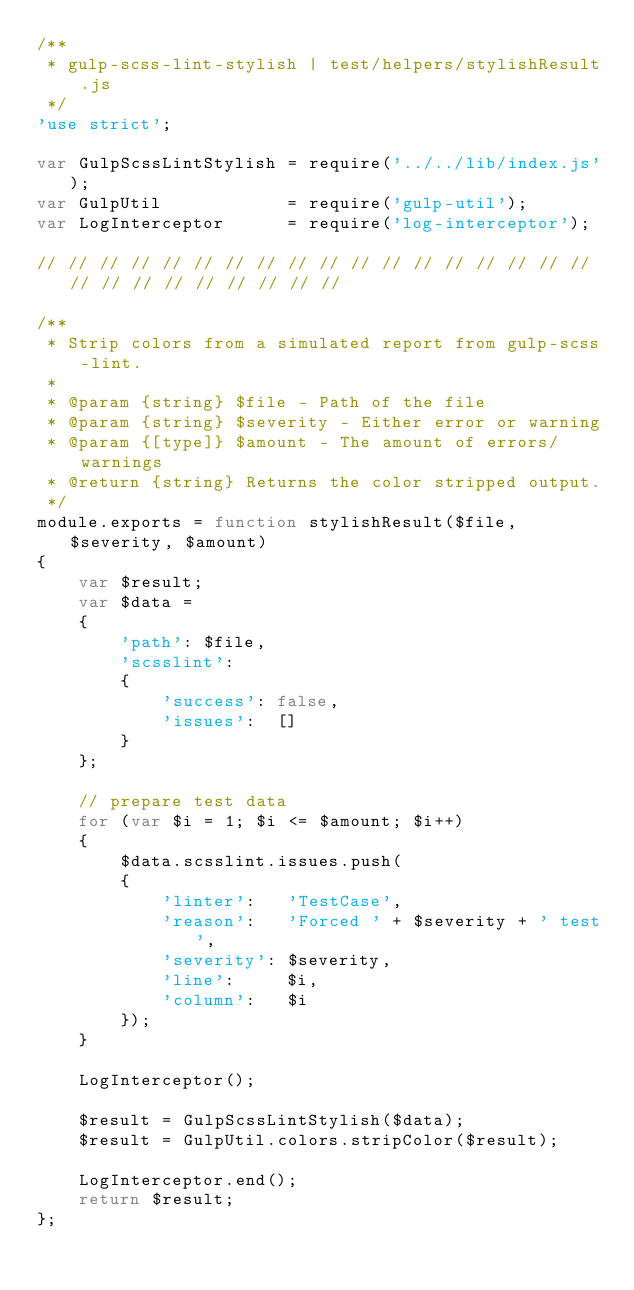Convert code to text. <code><loc_0><loc_0><loc_500><loc_500><_JavaScript_>/**
 * gulp-scss-lint-stylish | test/helpers/stylishResult.js
 */
'use strict';

var GulpScssLintStylish = require('../../lib/index.js');
var GulpUtil            = require('gulp-util');
var LogInterceptor      = require('log-interceptor');

// // // // // // // // // // // // // // // // // // // // // // // // // // //

/**
 * Strip colors from a simulated report from gulp-scss-lint.
 *
 * @param {string} $file - Path of the file
 * @param {string} $severity - Either error or warning
 * @param {[type]} $amount - The amount of errors/warnings
 * @return {string} Returns the color stripped output.
 */
module.exports = function stylishResult($file, $severity, $amount)
{
    var $result;
    var $data =
    {
        'path': $file,
        'scsslint':
        {
            'success': false,
            'issues':  []
        }
    };

    // prepare test data
    for (var $i = 1; $i <= $amount; $i++)
    {
        $data.scsslint.issues.push(
        {
            'linter':   'TestCase',
            'reason':   'Forced ' + $severity + ' test',
            'severity': $severity,
            'line':     $i,
            'column':   $i
        });
    }

    LogInterceptor();

    $result = GulpScssLintStylish($data);
    $result = GulpUtil.colors.stripColor($result);

    LogInterceptor.end();
    return $result;
};
</code> 